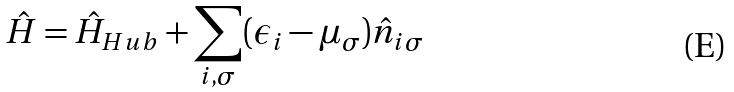<formula> <loc_0><loc_0><loc_500><loc_500>\hat { H } = \hat { H } _ { H u b } + \sum _ { i , \sigma } ( \epsilon _ { i } - \mu _ { \sigma } ) \hat { n } _ { i \sigma }</formula> 